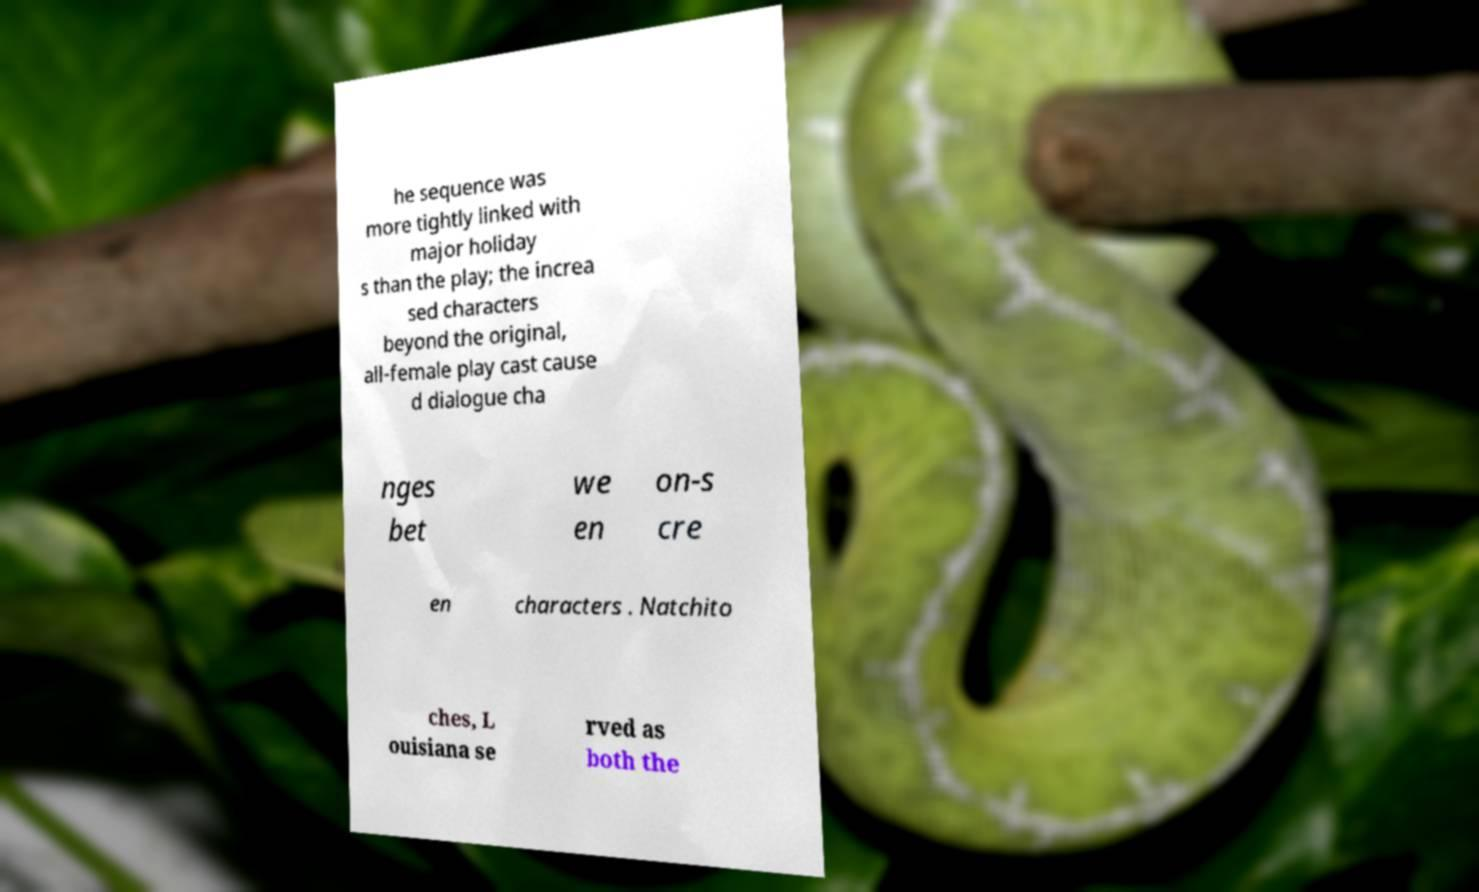Can you read and provide the text displayed in the image?This photo seems to have some interesting text. Can you extract and type it out for me? he sequence was more tightly linked with major holiday s than the play; the increa sed characters beyond the original, all-female play cast cause d dialogue cha nges bet we en on-s cre en characters . Natchito ches, L ouisiana se rved as both the 